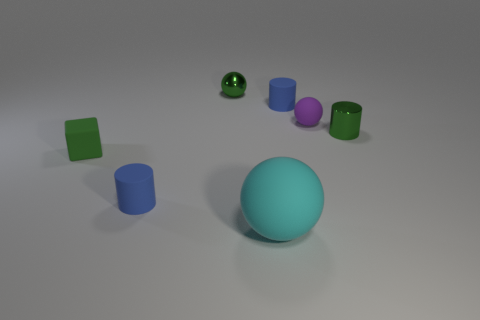Add 2 small green rubber blocks. How many objects exist? 9 Subtract all blocks. How many objects are left? 6 Add 2 small rubber blocks. How many small rubber blocks are left? 3 Add 4 green cylinders. How many green cylinders exist? 5 Subtract 1 green balls. How many objects are left? 6 Subtract all large green matte spheres. Subtract all cubes. How many objects are left? 6 